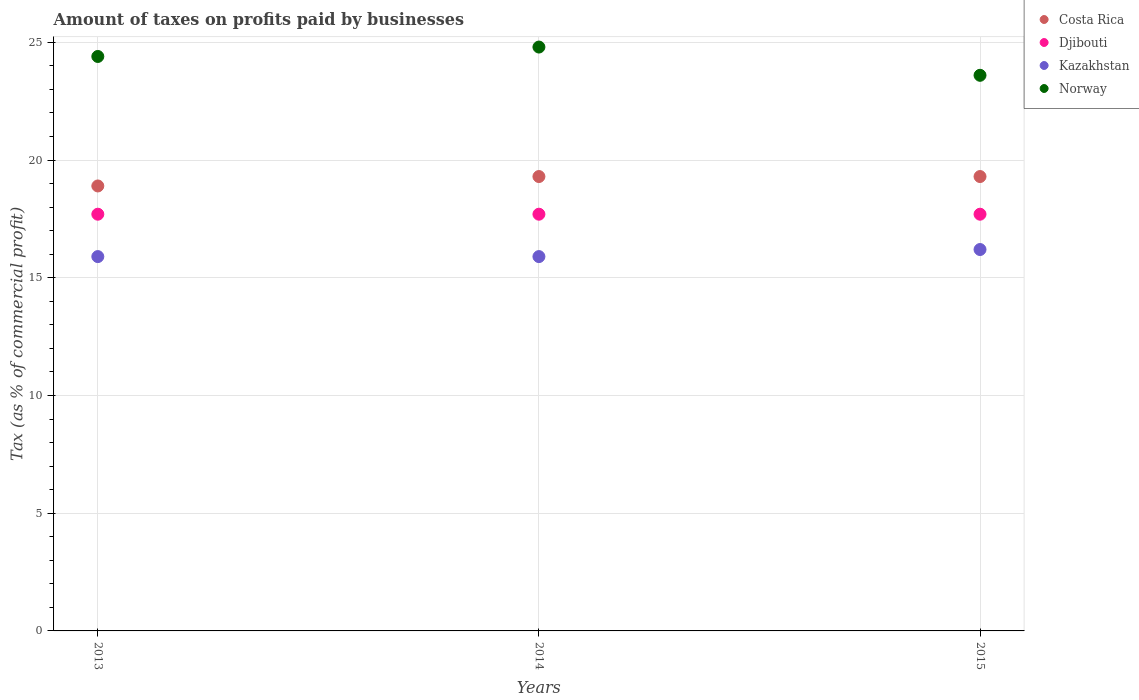What is the percentage of taxes paid by businesses in Costa Rica in 2014?
Provide a succinct answer. 19.3. Across all years, what is the minimum percentage of taxes paid by businesses in Costa Rica?
Your answer should be very brief. 18.9. In which year was the percentage of taxes paid by businesses in Djibouti minimum?
Offer a terse response. 2013. What is the difference between the percentage of taxes paid by businesses in Kazakhstan in 2015 and the percentage of taxes paid by businesses in Norway in 2014?
Ensure brevity in your answer.  -8.6. What is the average percentage of taxes paid by businesses in Kazakhstan per year?
Offer a very short reply. 16. In the year 2015, what is the difference between the percentage of taxes paid by businesses in Norway and percentage of taxes paid by businesses in Djibouti?
Your answer should be very brief. 5.9. What is the ratio of the percentage of taxes paid by businesses in Norway in 2013 to that in 2014?
Keep it short and to the point. 0.98. Is the percentage of taxes paid by businesses in Norway in 2014 less than that in 2015?
Provide a succinct answer. No. What is the difference between the highest and the second highest percentage of taxes paid by businesses in Kazakhstan?
Provide a succinct answer. 0.3. What is the difference between the highest and the lowest percentage of taxes paid by businesses in Norway?
Offer a very short reply. 1.2. Is it the case that in every year, the sum of the percentage of taxes paid by businesses in Kazakhstan and percentage of taxes paid by businesses in Djibouti  is greater than the percentage of taxes paid by businesses in Norway?
Provide a succinct answer. Yes. Is the percentage of taxes paid by businesses in Djibouti strictly less than the percentage of taxes paid by businesses in Kazakhstan over the years?
Offer a very short reply. No. How many dotlines are there?
Make the answer very short. 4. What is the difference between two consecutive major ticks on the Y-axis?
Provide a short and direct response. 5. Does the graph contain any zero values?
Provide a succinct answer. No. How many legend labels are there?
Provide a succinct answer. 4. How are the legend labels stacked?
Provide a short and direct response. Vertical. What is the title of the graph?
Offer a very short reply. Amount of taxes on profits paid by businesses. What is the label or title of the Y-axis?
Offer a very short reply. Tax (as % of commercial profit). What is the Tax (as % of commercial profit) of Djibouti in 2013?
Make the answer very short. 17.7. What is the Tax (as % of commercial profit) in Norway in 2013?
Keep it short and to the point. 24.4. What is the Tax (as % of commercial profit) in Costa Rica in 2014?
Your answer should be very brief. 19.3. What is the Tax (as % of commercial profit) of Norway in 2014?
Give a very brief answer. 24.8. What is the Tax (as % of commercial profit) in Costa Rica in 2015?
Your answer should be compact. 19.3. What is the Tax (as % of commercial profit) of Djibouti in 2015?
Keep it short and to the point. 17.7. What is the Tax (as % of commercial profit) of Kazakhstan in 2015?
Provide a succinct answer. 16.2. What is the Tax (as % of commercial profit) in Norway in 2015?
Offer a terse response. 23.6. Across all years, what is the maximum Tax (as % of commercial profit) in Costa Rica?
Your answer should be very brief. 19.3. Across all years, what is the maximum Tax (as % of commercial profit) in Norway?
Offer a terse response. 24.8. Across all years, what is the minimum Tax (as % of commercial profit) of Costa Rica?
Provide a short and direct response. 18.9. Across all years, what is the minimum Tax (as % of commercial profit) of Kazakhstan?
Your answer should be very brief. 15.9. Across all years, what is the minimum Tax (as % of commercial profit) of Norway?
Keep it short and to the point. 23.6. What is the total Tax (as % of commercial profit) of Costa Rica in the graph?
Give a very brief answer. 57.5. What is the total Tax (as % of commercial profit) in Djibouti in the graph?
Provide a short and direct response. 53.1. What is the total Tax (as % of commercial profit) of Kazakhstan in the graph?
Make the answer very short. 48. What is the total Tax (as % of commercial profit) of Norway in the graph?
Give a very brief answer. 72.8. What is the difference between the Tax (as % of commercial profit) in Djibouti in 2013 and that in 2015?
Provide a succinct answer. 0. What is the difference between the Tax (as % of commercial profit) in Norway in 2013 and that in 2015?
Offer a very short reply. 0.8. What is the difference between the Tax (as % of commercial profit) in Norway in 2014 and that in 2015?
Make the answer very short. 1.2. What is the difference between the Tax (as % of commercial profit) of Costa Rica in 2013 and the Tax (as % of commercial profit) of Djibouti in 2014?
Offer a very short reply. 1.2. What is the difference between the Tax (as % of commercial profit) of Costa Rica in 2013 and the Tax (as % of commercial profit) of Kazakhstan in 2014?
Ensure brevity in your answer.  3. What is the difference between the Tax (as % of commercial profit) of Djibouti in 2013 and the Tax (as % of commercial profit) of Kazakhstan in 2014?
Your response must be concise. 1.8. What is the difference between the Tax (as % of commercial profit) of Djibouti in 2013 and the Tax (as % of commercial profit) of Norway in 2014?
Provide a short and direct response. -7.1. What is the difference between the Tax (as % of commercial profit) of Djibouti in 2013 and the Tax (as % of commercial profit) of Kazakhstan in 2015?
Offer a terse response. 1.5. What is the difference between the Tax (as % of commercial profit) in Djibouti in 2013 and the Tax (as % of commercial profit) in Norway in 2015?
Your answer should be compact. -5.9. What is the difference between the Tax (as % of commercial profit) in Costa Rica in 2014 and the Tax (as % of commercial profit) in Norway in 2015?
Offer a very short reply. -4.3. What is the difference between the Tax (as % of commercial profit) in Djibouti in 2014 and the Tax (as % of commercial profit) in Kazakhstan in 2015?
Make the answer very short. 1.5. What is the average Tax (as % of commercial profit) of Costa Rica per year?
Provide a succinct answer. 19.17. What is the average Tax (as % of commercial profit) of Djibouti per year?
Give a very brief answer. 17.7. What is the average Tax (as % of commercial profit) in Kazakhstan per year?
Keep it short and to the point. 16. What is the average Tax (as % of commercial profit) in Norway per year?
Ensure brevity in your answer.  24.27. In the year 2013, what is the difference between the Tax (as % of commercial profit) in Costa Rica and Tax (as % of commercial profit) in Djibouti?
Provide a short and direct response. 1.2. In the year 2013, what is the difference between the Tax (as % of commercial profit) of Djibouti and Tax (as % of commercial profit) of Kazakhstan?
Your response must be concise. 1.8. In the year 2013, what is the difference between the Tax (as % of commercial profit) in Djibouti and Tax (as % of commercial profit) in Norway?
Make the answer very short. -6.7. In the year 2014, what is the difference between the Tax (as % of commercial profit) in Costa Rica and Tax (as % of commercial profit) in Djibouti?
Your answer should be compact. 1.6. In the year 2014, what is the difference between the Tax (as % of commercial profit) in Costa Rica and Tax (as % of commercial profit) in Kazakhstan?
Offer a very short reply. 3.4. In the year 2014, what is the difference between the Tax (as % of commercial profit) in Djibouti and Tax (as % of commercial profit) in Norway?
Offer a terse response. -7.1. In the year 2014, what is the difference between the Tax (as % of commercial profit) of Kazakhstan and Tax (as % of commercial profit) of Norway?
Offer a terse response. -8.9. In the year 2015, what is the difference between the Tax (as % of commercial profit) of Costa Rica and Tax (as % of commercial profit) of Djibouti?
Your answer should be compact. 1.6. In the year 2015, what is the difference between the Tax (as % of commercial profit) of Costa Rica and Tax (as % of commercial profit) of Norway?
Make the answer very short. -4.3. In the year 2015, what is the difference between the Tax (as % of commercial profit) in Djibouti and Tax (as % of commercial profit) in Kazakhstan?
Give a very brief answer. 1.5. In the year 2015, what is the difference between the Tax (as % of commercial profit) in Djibouti and Tax (as % of commercial profit) in Norway?
Give a very brief answer. -5.9. In the year 2015, what is the difference between the Tax (as % of commercial profit) of Kazakhstan and Tax (as % of commercial profit) of Norway?
Ensure brevity in your answer.  -7.4. What is the ratio of the Tax (as % of commercial profit) in Costa Rica in 2013 to that in 2014?
Offer a very short reply. 0.98. What is the ratio of the Tax (as % of commercial profit) of Djibouti in 2013 to that in 2014?
Offer a very short reply. 1. What is the ratio of the Tax (as % of commercial profit) in Norway in 2013 to that in 2014?
Give a very brief answer. 0.98. What is the ratio of the Tax (as % of commercial profit) in Costa Rica in 2013 to that in 2015?
Your answer should be very brief. 0.98. What is the ratio of the Tax (as % of commercial profit) of Djibouti in 2013 to that in 2015?
Ensure brevity in your answer.  1. What is the ratio of the Tax (as % of commercial profit) in Kazakhstan in 2013 to that in 2015?
Give a very brief answer. 0.98. What is the ratio of the Tax (as % of commercial profit) in Norway in 2013 to that in 2015?
Offer a very short reply. 1.03. What is the ratio of the Tax (as % of commercial profit) in Costa Rica in 2014 to that in 2015?
Keep it short and to the point. 1. What is the ratio of the Tax (as % of commercial profit) of Kazakhstan in 2014 to that in 2015?
Give a very brief answer. 0.98. What is the ratio of the Tax (as % of commercial profit) in Norway in 2014 to that in 2015?
Your answer should be compact. 1.05. What is the difference between the highest and the second highest Tax (as % of commercial profit) of Djibouti?
Make the answer very short. 0. What is the difference between the highest and the second highest Tax (as % of commercial profit) in Kazakhstan?
Keep it short and to the point. 0.3. What is the difference between the highest and the second highest Tax (as % of commercial profit) in Norway?
Your response must be concise. 0.4. What is the difference between the highest and the lowest Tax (as % of commercial profit) of Costa Rica?
Ensure brevity in your answer.  0.4. What is the difference between the highest and the lowest Tax (as % of commercial profit) of Djibouti?
Offer a terse response. 0. 